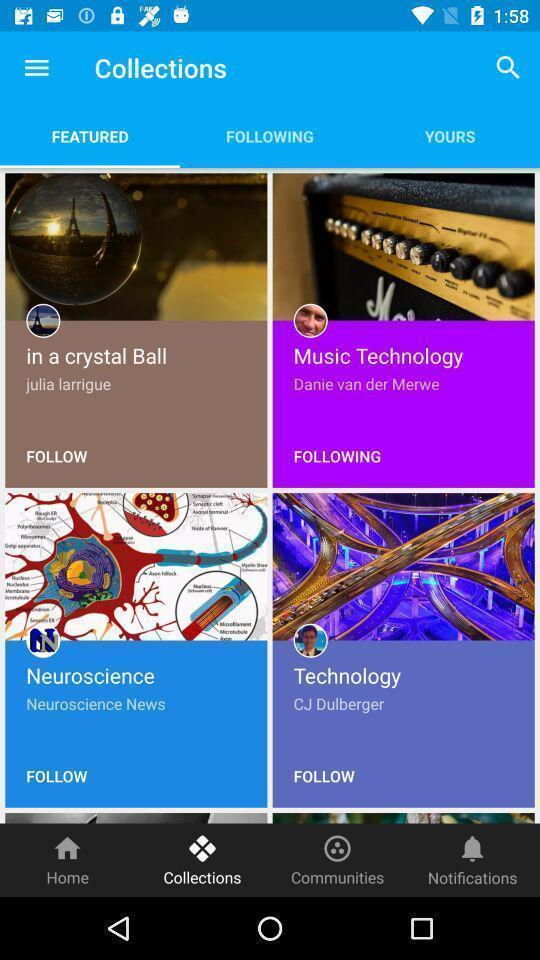Give me a summary of this screen capture. Page displaying list of images in app. 